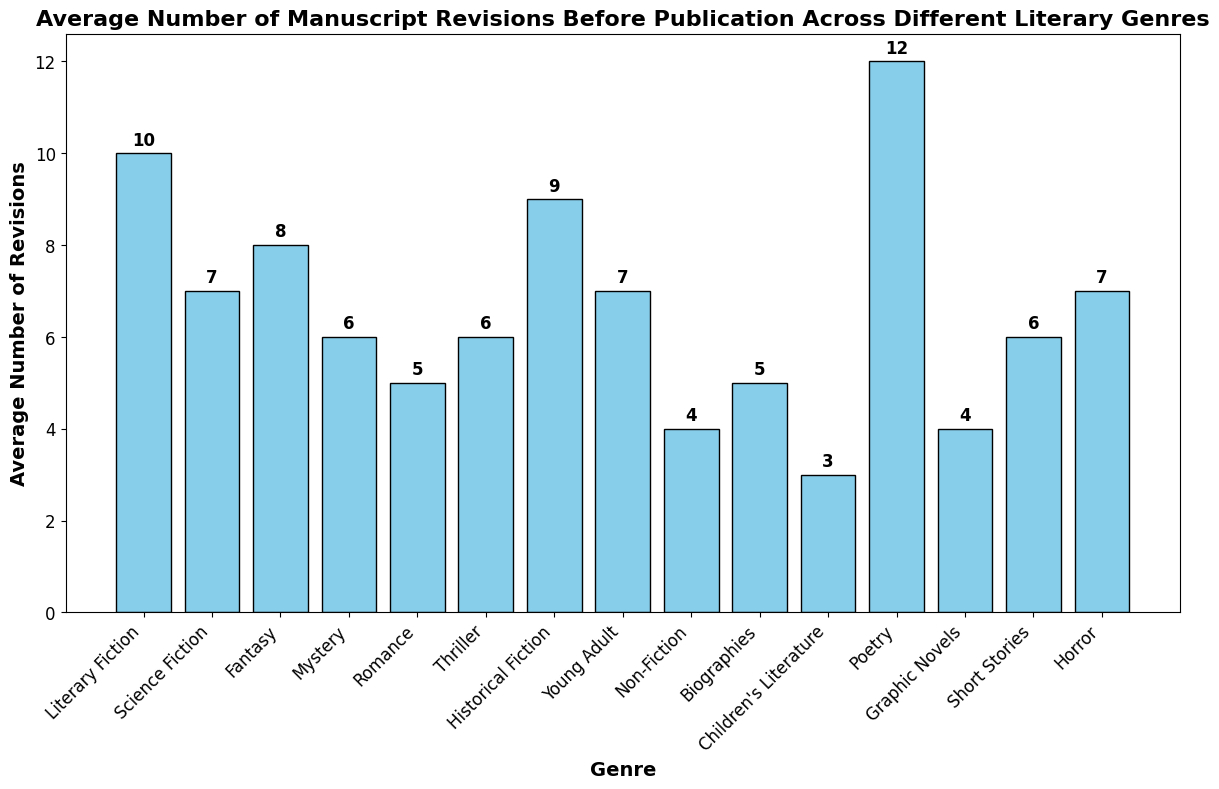What's the average number of revisions for genres with more than 7 revisions? First, identify the genres with average revisions greater than 7: Literary Fiction (10), Fantasy (8), Historical Fiction (9), and Poetry (12). Sum these values: 10 + 8 + 9 + 12 = 39. Now, divide by the number of these genres, which is 4. So, the average is 39 / 4 = 9.75
Answer: 9.75 Which genre has the highest average number of revisions? By scanning the bars, we notice that Poetry has the tallest bar, indicating the highest average number of revisions which is 12
Answer: Poetry How many genres have fewer average revisions than Mystery? Mystery has an average of 6 revisions. By quickly checking the bars, Non-Fiction, Biographies, Children's Literature, and Graphic Novels have fewer revisions which total to 4 genres
Answer: 4 How many more average revisions does Literary Fiction have compared to Romance? Literary Fiction has 10 revisions, and Romance has 5. The difference is 10 - 5 = 5
Answer: 5 What's the combined average number of revisions for Science Fiction and Young Adult genres? Science Fiction has 7 revisions and Young Adult also has 7 revisions. Adding these gives 7 + 7 = 14
Answer: 14 Which genres have an average number of revisions equal to Thriller? Thriller has an average of 6 revisions. By comparing, we see that Mystery and Short Stories also have 6 revisions
Answer: Mystery, Short Stories What is the median value of the average number of revisions across all genres? List the average revisions in ascending order: 3, 4, 4, 5, 5, 6, 6, 6, 7, 7, 7, 8, 9, 10, 12. For an odd number of observations (15), the median is the middle value of the sorted list, which is 6
Answer: 6 What's the difference between the genre with the highest and lowest average number of revisions? The highest is Poetry with 12 revisions, and the lowest is Children's Literature with 3 revisions. The difference is 12 - 3 = 9
Answer: 9 Among Fiction-related genres, which one has the second highest average number of revisions? The Fiction-related genres are Literary Fiction (10), Science Fiction (7), Fantasy (8), Historical Fiction (9), Young Adult (7), Graphic Novels (4), Short Stories (6), Horror (7). The second highest value is Historical Fiction with 9 revisions
Answer: Historical Fiction 